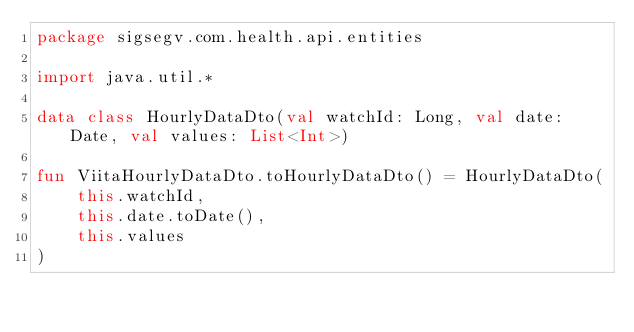<code> <loc_0><loc_0><loc_500><loc_500><_Kotlin_>package sigsegv.com.health.api.entities

import java.util.*

data class HourlyDataDto(val watchId: Long, val date: Date, val values: List<Int>)

fun ViitaHourlyDataDto.toHourlyDataDto() = HourlyDataDto(
    this.watchId,
    this.date.toDate(),
    this.values
)</code> 